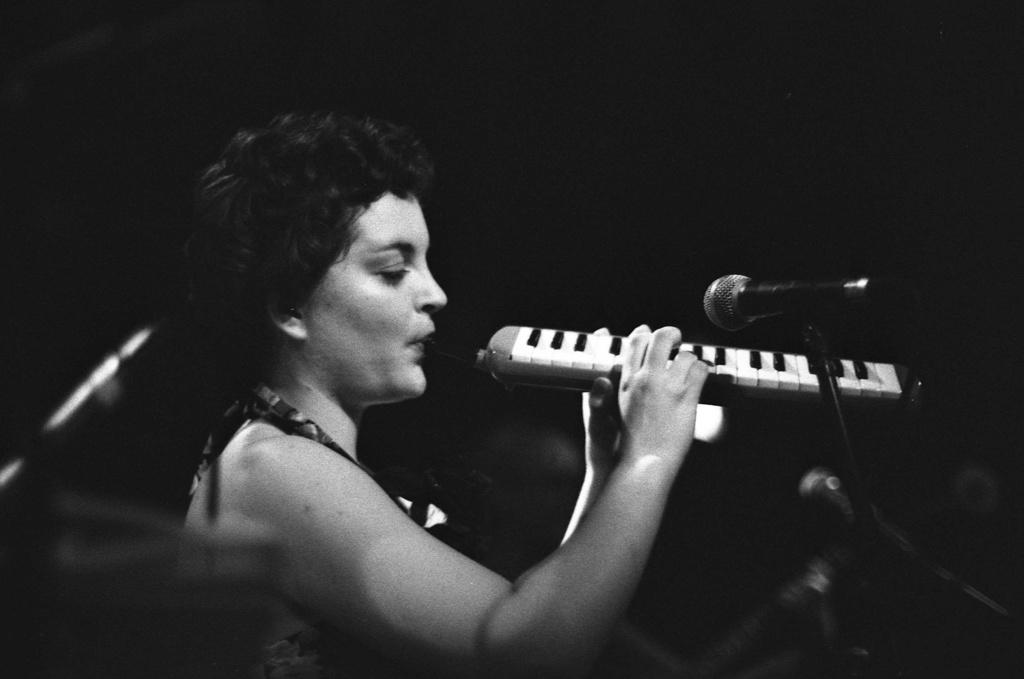Who is the main subject of the subject in the image? There is a woman in the image. What is the woman doing in the image? The woman is playing a musical instrument. What object is present in the image that is commonly used for amplifying sound? There is a microphone (mic) in the image. How many legs can be seen on the card in the image? There is no card present in the image, and therefore no legs can be seen on a card. 